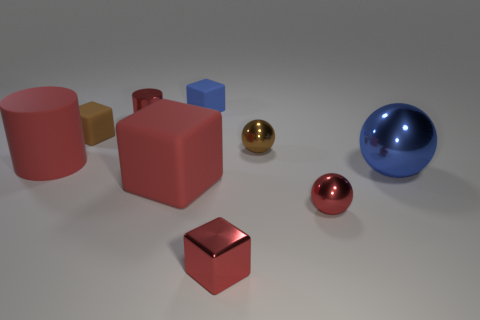Do the metal thing left of the tiny red block and the large matte cylinder have the same color?
Provide a succinct answer. Yes. Is the color of the large matte cube the same as the rubber cylinder?
Provide a short and direct response. Yes. What is the size of the red shiny object that is the same shape as the blue rubber thing?
Your answer should be compact. Small. There is a block that is to the right of the large red matte block and in front of the large shiny thing; what color is it?
Ensure brevity in your answer.  Red. Does the large cylinder have the same material as the small sphere that is in front of the big red cylinder?
Provide a short and direct response. No. Are there fewer large blue metal things that are in front of the tiny red metal ball than red cubes?
Ensure brevity in your answer.  Yes. What number of other things are there of the same shape as the big blue shiny object?
Your response must be concise. 2. Is there anything else of the same color as the big cube?
Ensure brevity in your answer.  Yes. There is a big metallic ball; does it have the same color as the small object behind the small shiny cylinder?
Offer a very short reply. Yes. What number of other objects are there of the same size as the blue cube?
Ensure brevity in your answer.  5. 